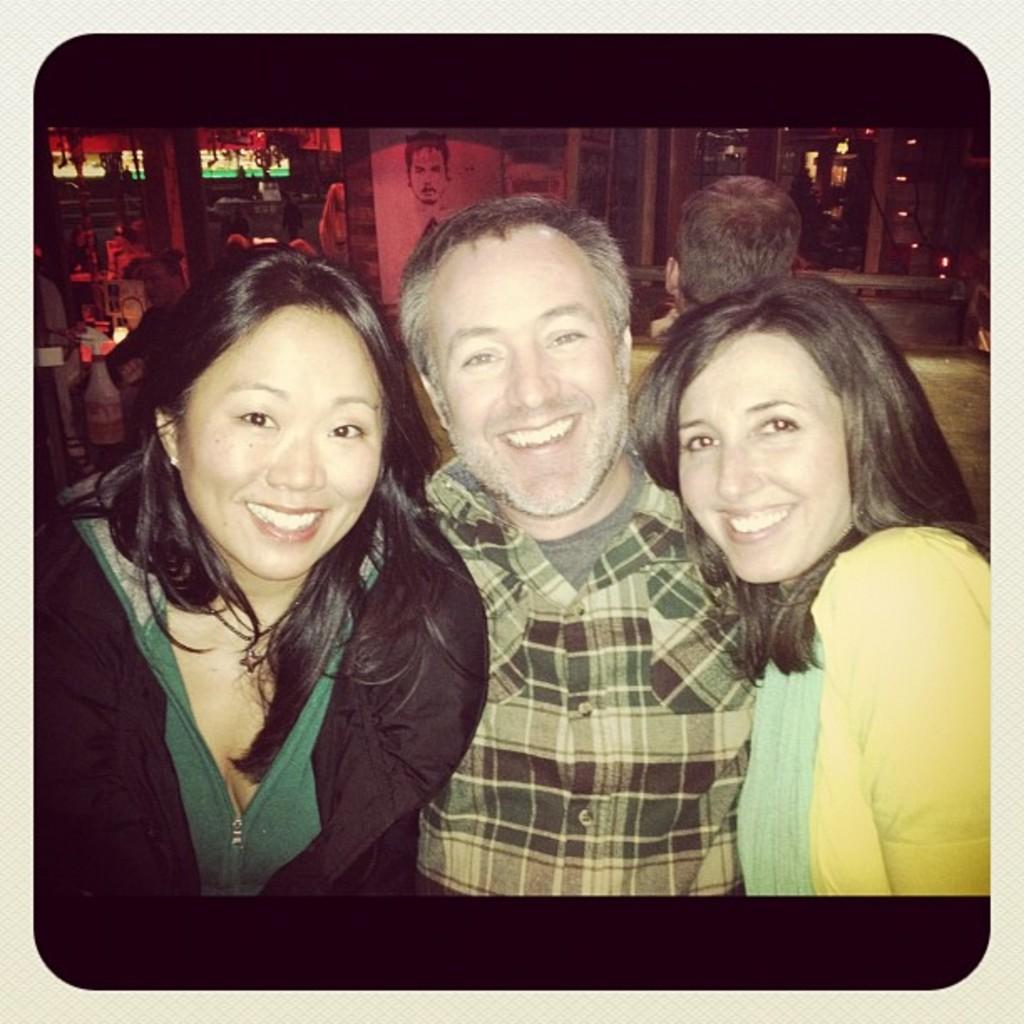In one or two sentences, can you explain what this image depicts? In this image, we can see three people are watching and smiling. Background we can see few people, will, some objects, lights. The borders of the image, we can see white color. At the top and bottom of the image, we can see black color. 